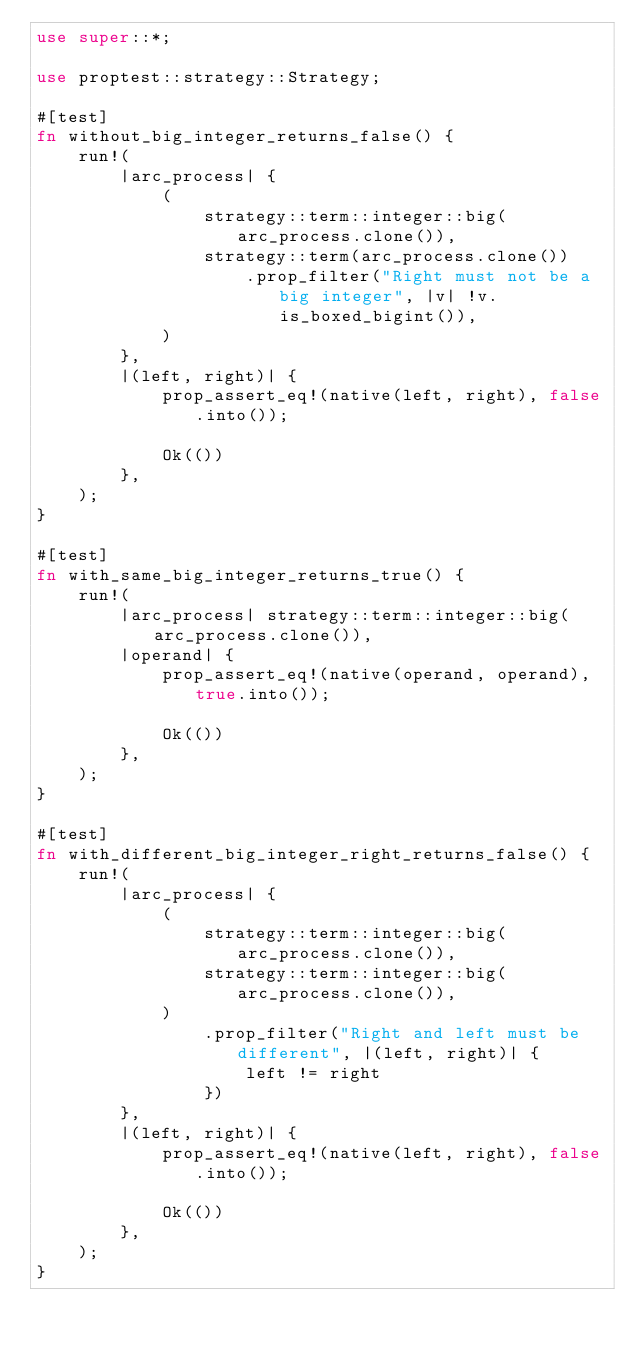Convert code to text. <code><loc_0><loc_0><loc_500><loc_500><_Rust_>use super::*;

use proptest::strategy::Strategy;

#[test]
fn without_big_integer_returns_false() {
    run!(
        |arc_process| {
            (
                strategy::term::integer::big(arc_process.clone()),
                strategy::term(arc_process.clone())
                    .prop_filter("Right must not be a big integer", |v| !v.is_boxed_bigint()),
            )
        },
        |(left, right)| {
            prop_assert_eq!(native(left, right), false.into());

            Ok(())
        },
    );
}

#[test]
fn with_same_big_integer_returns_true() {
    run!(
        |arc_process| strategy::term::integer::big(arc_process.clone()),
        |operand| {
            prop_assert_eq!(native(operand, operand), true.into());

            Ok(())
        },
    );
}

#[test]
fn with_different_big_integer_right_returns_false() {
    run!(
        |arc_process| {
            (
                strategy::term::integer::big(arc_process.clone()),
                strategy::term::integer::big(arc_process.clone()),
            )
                .prop_filter("Right and left must be different", |(left, right)| {
                    left != right
                })
        },
        |(left, right)| {
            prop_assert_eq!(native(left, right), false.into());

            Ok(())
        },
    );
}
</code> 